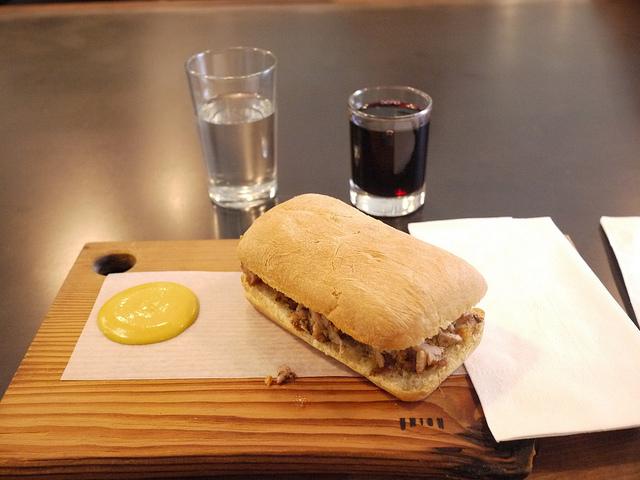Is this a sandwich?
Write a very short answer. Yes. Why is the yellow sauce placed on the side of the sandwich?
Short answer required. Mustard. How many glasses are there?
Keep it brief. 2. 